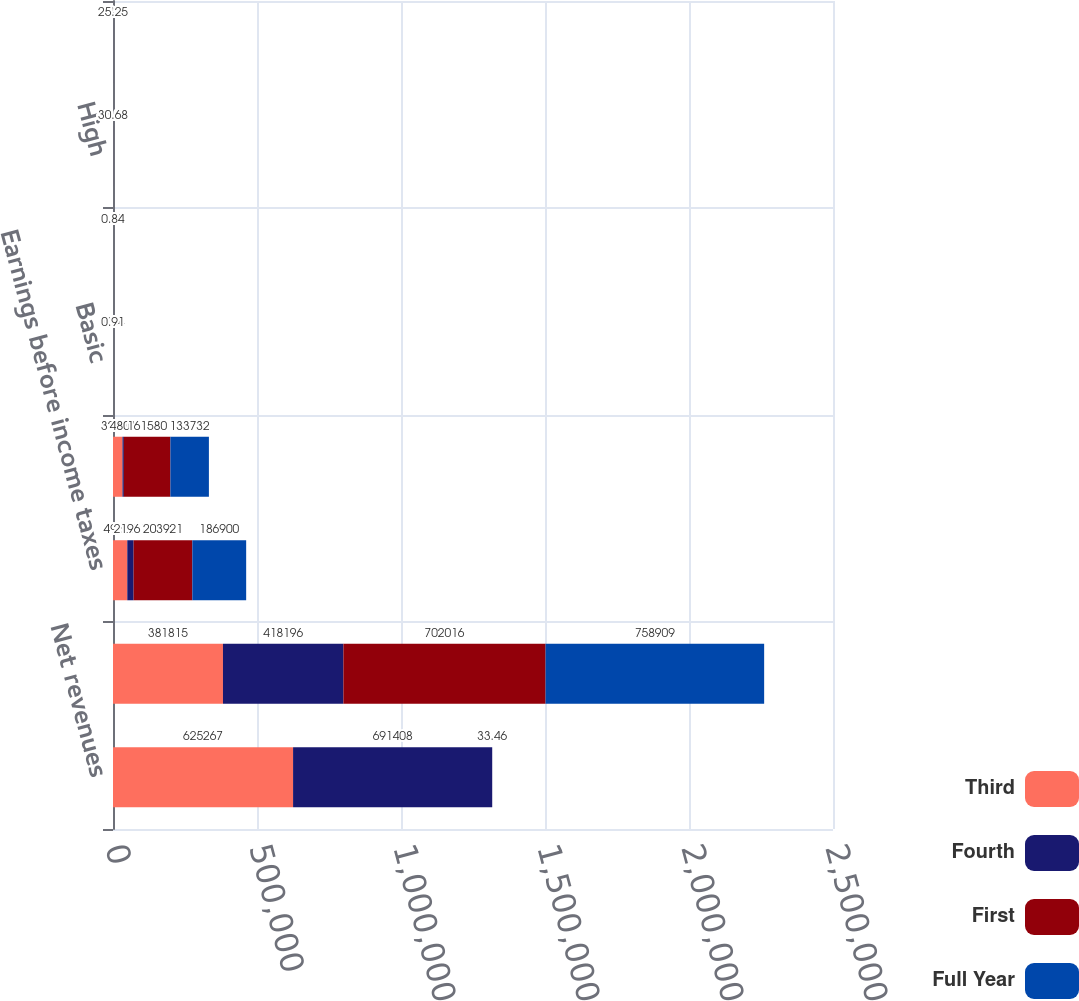Convert chart to OTSL. <chart><loc_0><loc_0><loc_500><loc_500><stacked_bar_chart><ecel><fcel>Net revenues<fcel>Gross profit<fcel>Earnings before income taxes<fcel>Net earnings<fcel>Basic<fcel>Diluted<fcel>High<fcel>Low<nl><fcel>Third<fcel>625267<fcel>381815<fcel>49600<fcel>32890<fcel>0.2<fcel>0.19<fcel>30.24<fcel>27.04<nl><fcel>Fourth<fcel>691408<fcel>418196<fcel>21961<fcel>4801<fcel>0.03<fcel>0.03<fcel>33.43<fcel>28.1<nl><fcel>First<fcel>33.46<fcel>702016<fcel>203921<fcel>161580<fcel>1.04<fcel>0.95<fcel>33.49<fcel>25.25<nl><fcel>Full Year<fcel>33.46<fcel>758909<fcel>186900<fcel>133732<fcel>0.91<fcel>0.84<fcel>30.68<fcel>25.25<nl></chart> 